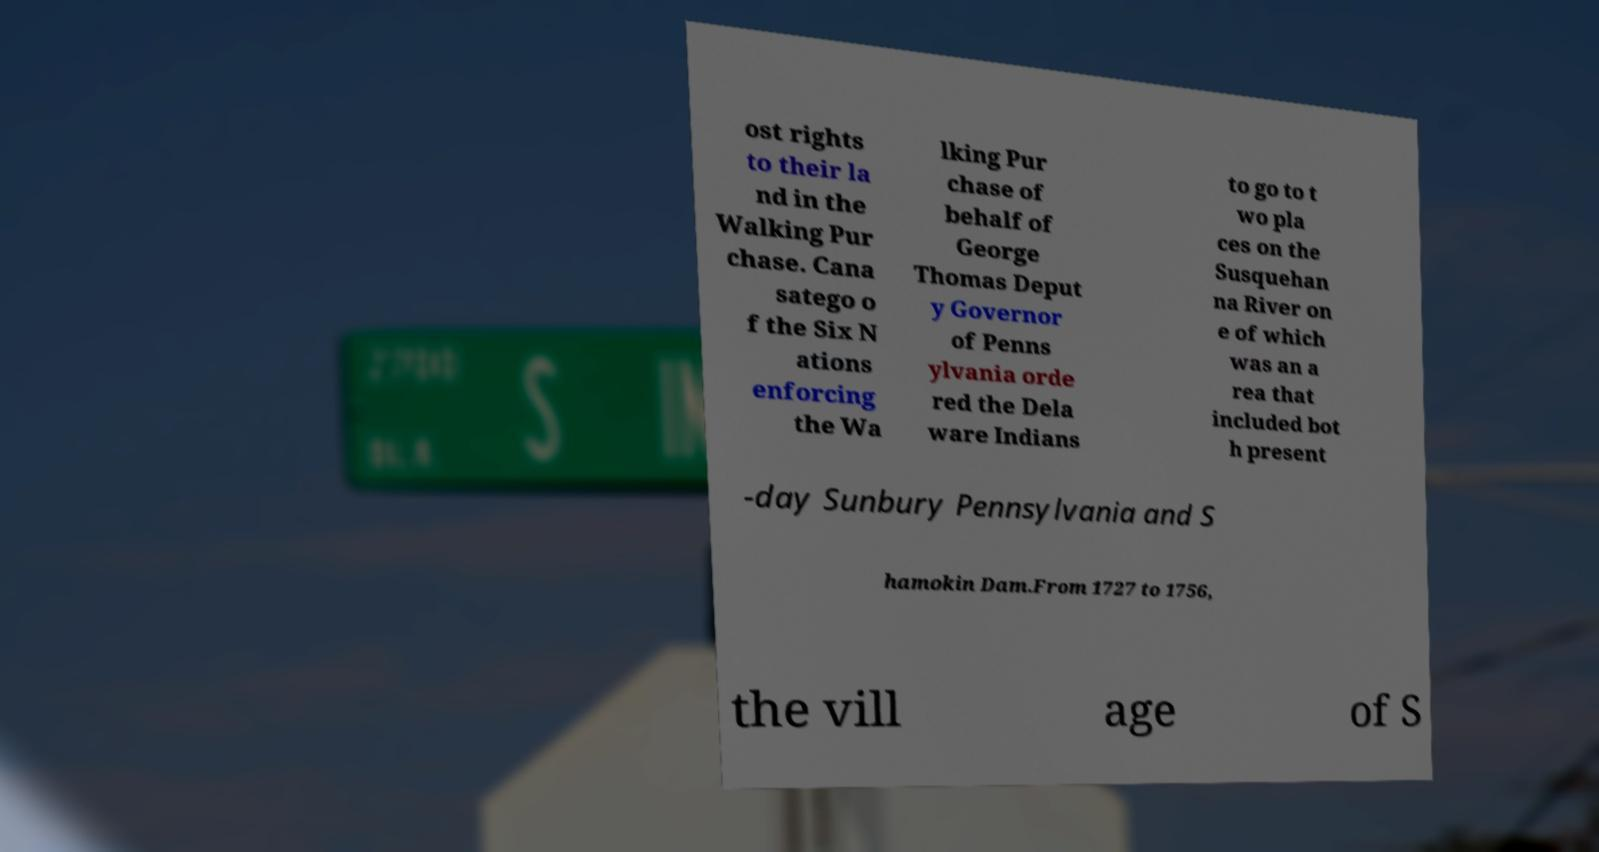Can you accurately transcribe the text from the provided image for me? ost rights to their la nd in the Walking Pur chase. Cana satego o f the Six N ations enforcing the Wa lking Pur chase of behalf of George Thomas Deput y Governor of Penns ylvania orde red the Dela ware Indians to go to t wo pla ces on the Susquehan na River on e of which was an a rea that included bot h present -day Sunbury Pennsylvania and S hamokin Dam.From 1727 to 1756, the vill age of S 